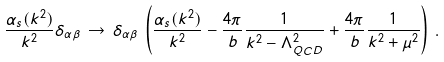Convert formula to latex. <formula><loc_0><loc_0><loc_500><loc_500>\frac { \alpha _ { s } ( k ^ { 2 } ) } { k ^ { 2 } } \delta _ { \alpha \beta } \, \rightarrow \, \delta _ { \alpha \beta } \, \left ( \frac { \alpha _ { s } ( k ^ { 2 } ) } { k ^ { 2 } } - \frac { 4 \pi } { b } \frac { 1 } { k ^ { 2 } - \Lambda _ { Q C D } ^ { 2 } } + \frac { 4 \pi } { b } \frac { 1 } { k ^ { 2 } + \mu ^ { 2 } } \right ) \, .</formula> 